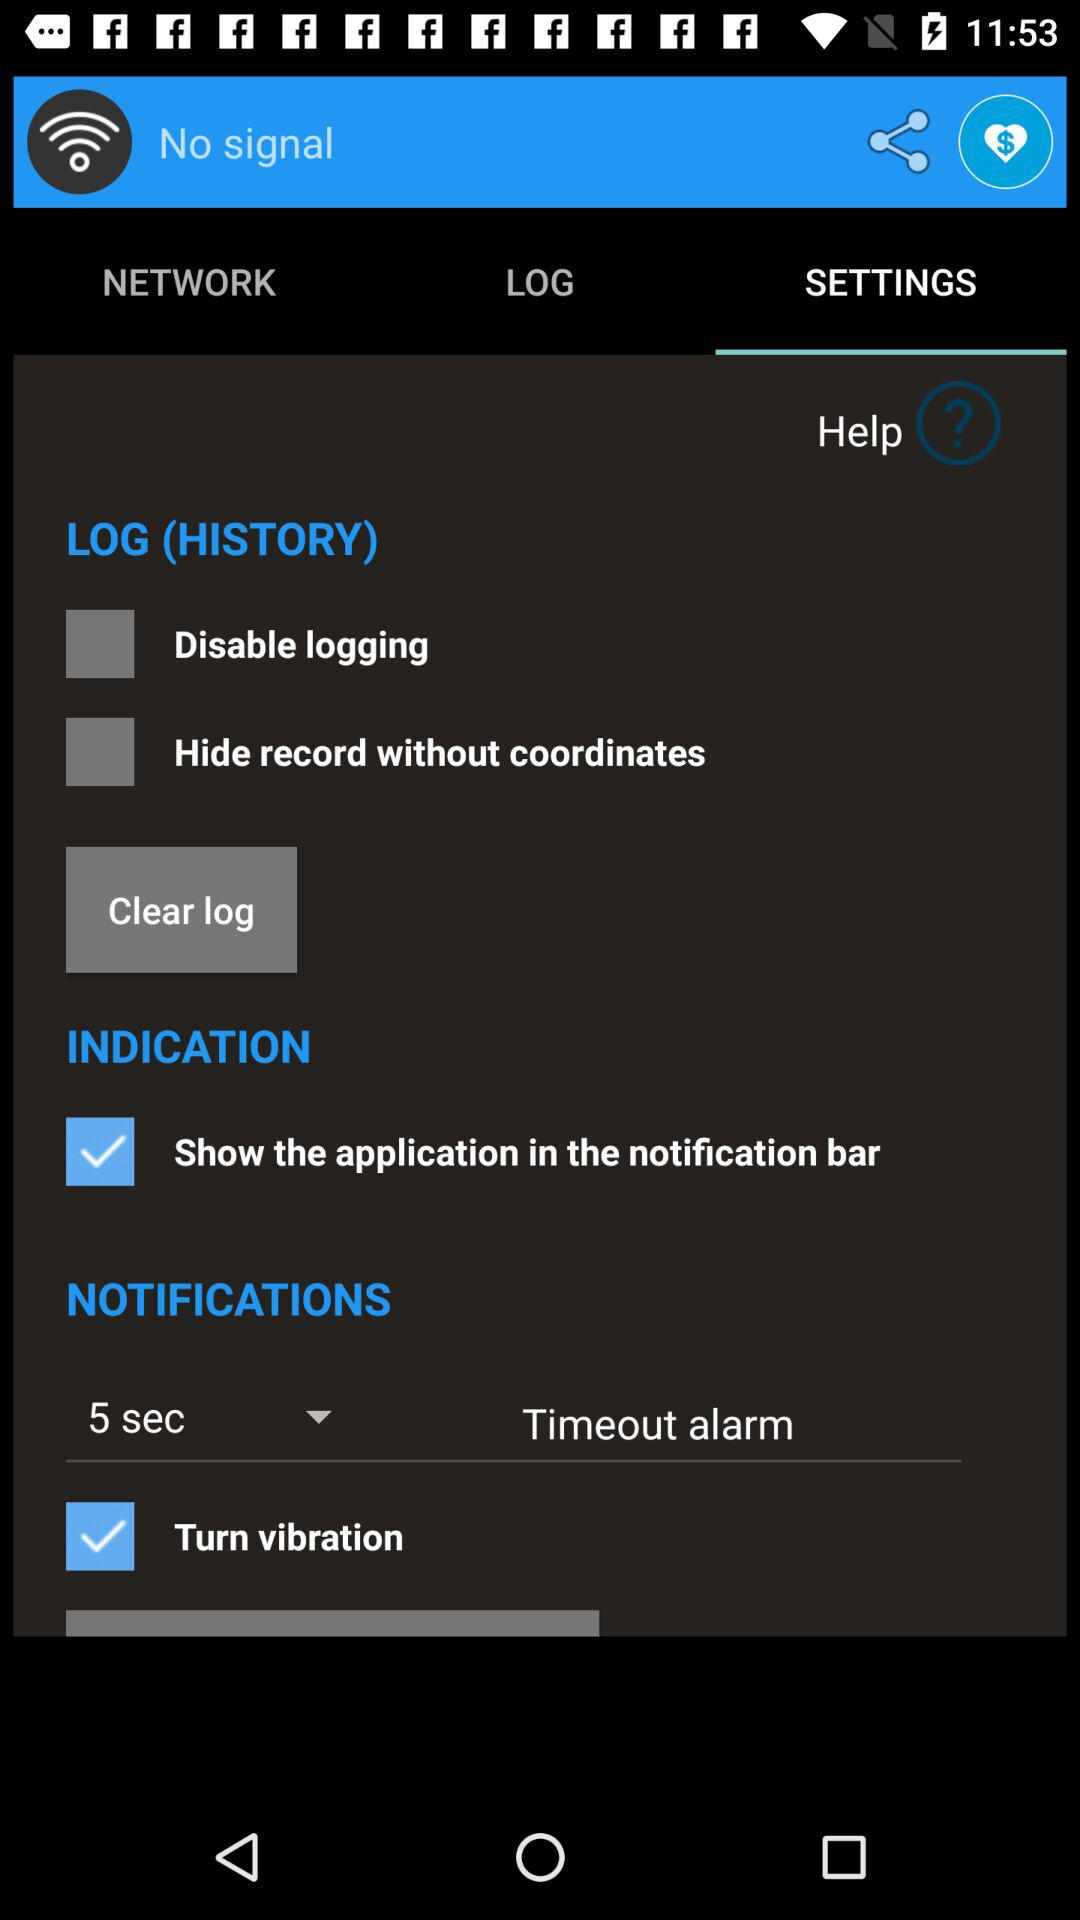What is the status of "Turn vibration"? The status is "on". 